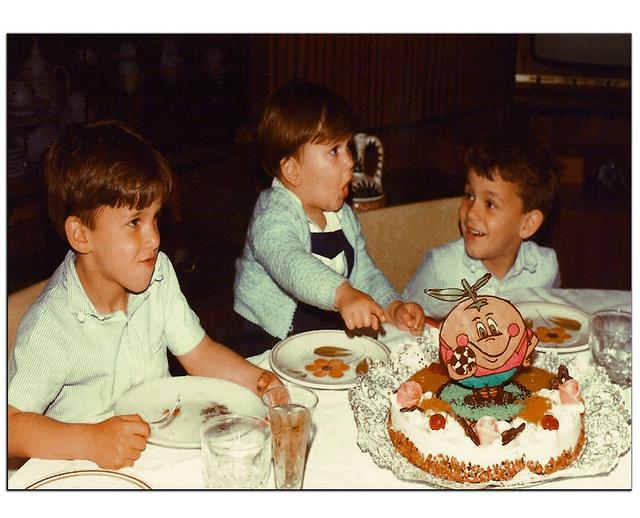What is in front of the kids?
Quick response, please. Cake. How many children are in the picture?
Write a very short answer. 3. What color is the flower on the plates?
Answer briefly. Orange. What meal is she going to eat?
Quick response, please. Cake. 